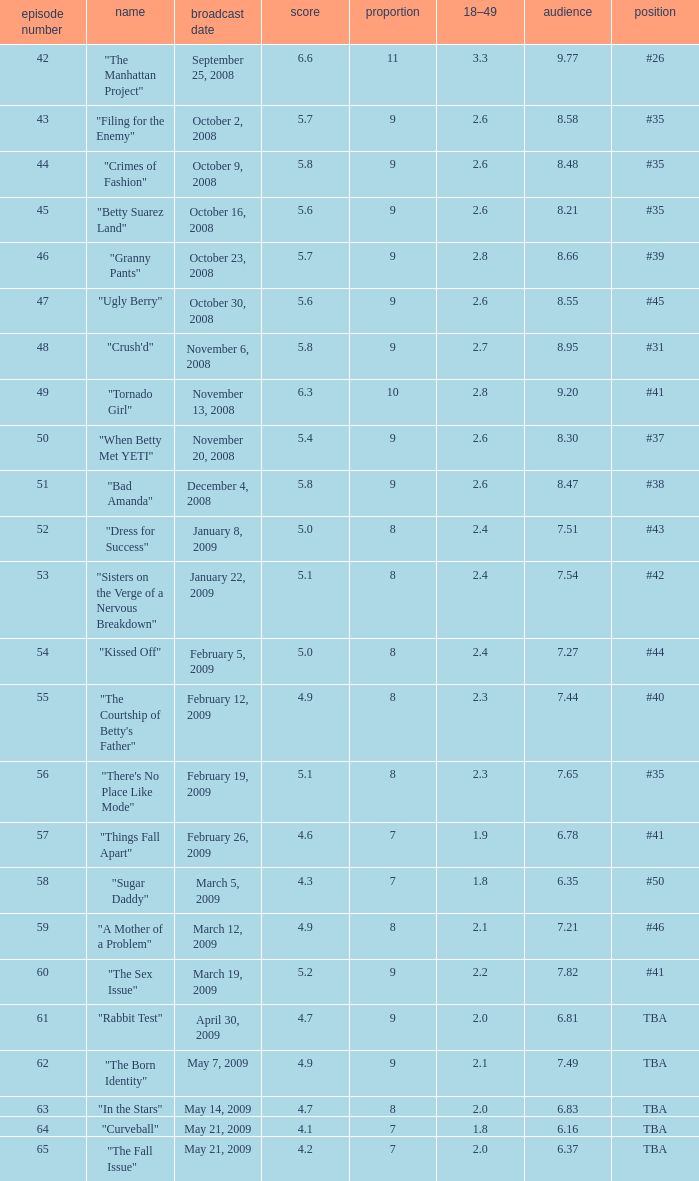What is the lowest Viewers that has an Episode #higher than 58 with a title of "curveball" less than 4.1 rating? None. 